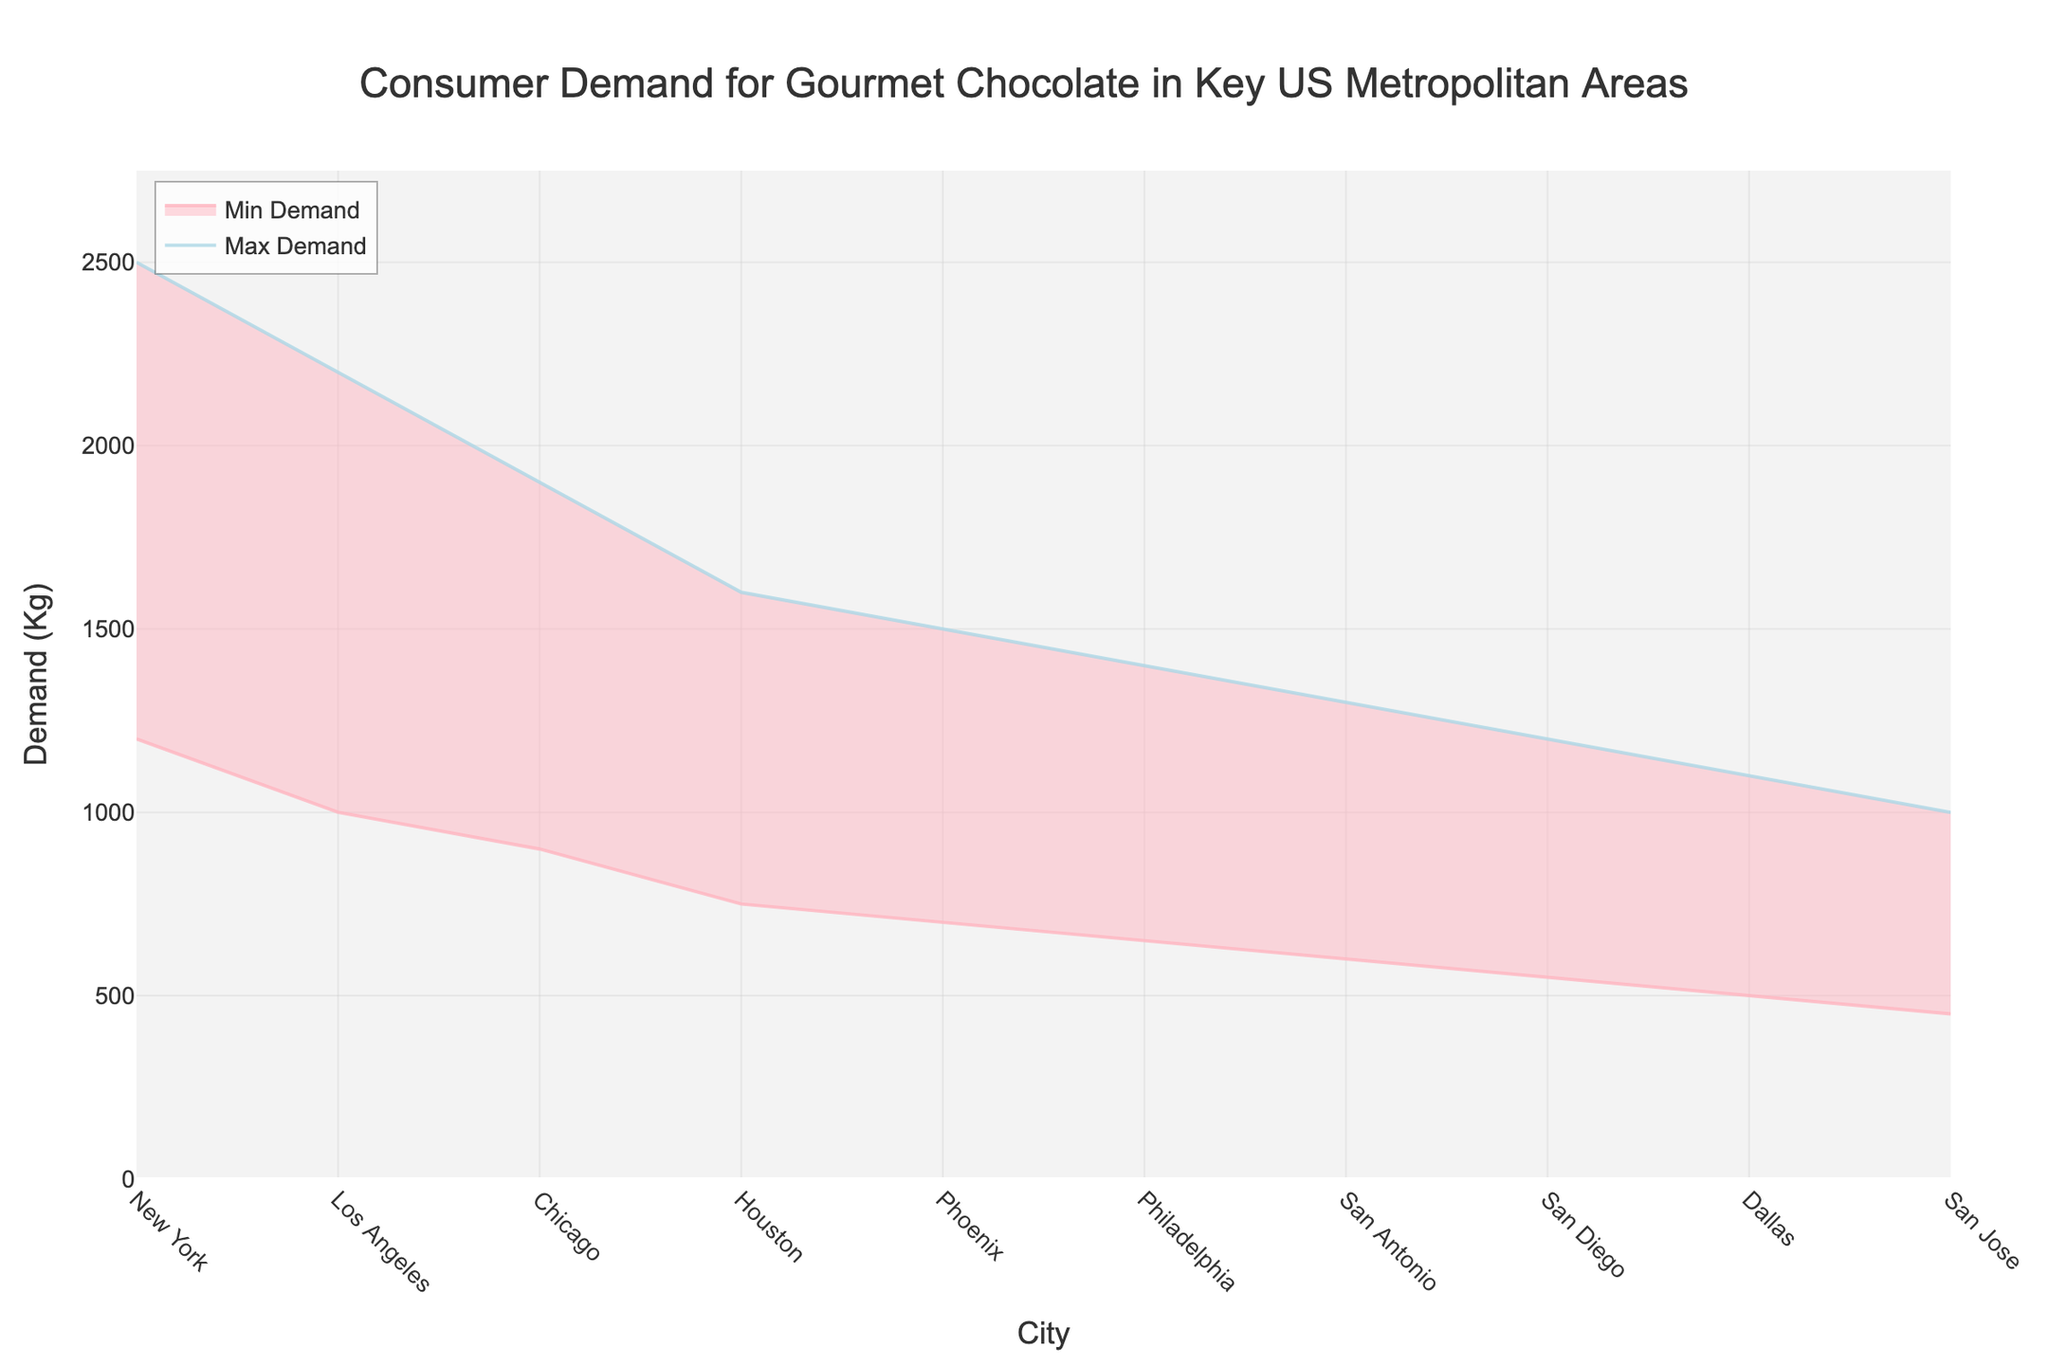What is the title of the figure? The title is displayed prominently at the top of the figure, indicating the overall content.
Answer: Consumer Demand for Gourmet Chocolate in Key US Metropolitan Areas Which city has the highest maximum demand for gourmet chocolate? The line representing the maximum demand reaches its highest point above the city name with the greatest maximum demand, making it visually easy to identify.
Answer: New York How many cities are analyzed in the plot? Each city is represented as a distinct data point along the x-axis, so counting these data points shows the number of cities analyzed.
Answer: 10 What color represents the maximum demand line? The line representing the maximum demand is visually distinct and is mentioned in the description as 'rgba(173, 216, 230, 0.8)', which translates to a light blue color visually.
Answer: Light blue What city has the smallest range of demand for gourmet chocolate? To determine the range, subtract the minimum demand from the maximum demand for each city. The city with the smallest difference has the smallest range.
Answer: San Jose Which city has a max demand of 1600 Kg? By observing the y-axis value that aligns with 1600 Kg on the maximum demand line, we can trace it down to the corresponding city on the x-axis.
Answer: Houston What is the average maximum demand across all cities? Sum all the maximum demand values (2500, 2200, etc.) and divide by the number of cities (10). (2500 + 2200 + 1900 + 1600 + 1500 + 1400 + 1300 + 1200 + 1100 + 1000)/10
Answer: 1770 Kg Which city shows no overlap between its minimum and maximum demand curves? Each city's demand range appears as a filled area between the minimum and maximum lines. If there's a distinct separation without overlap, identify that city.
Answer: None What is the difference in maximum demand between New York and San Jose? Subtract San Jose's maximum demand from New York's maximum demand. 2500 Kg (New York) - 1000 Kg (San Jose)
Answer: 1500 Kg Which city has the closest minimum demand to 550 Kg? By observing the y-axis value closest to 550 Kg on the minimum demand line, trace it down to the corresponding city on the x-axis.
Answer: San Diego 